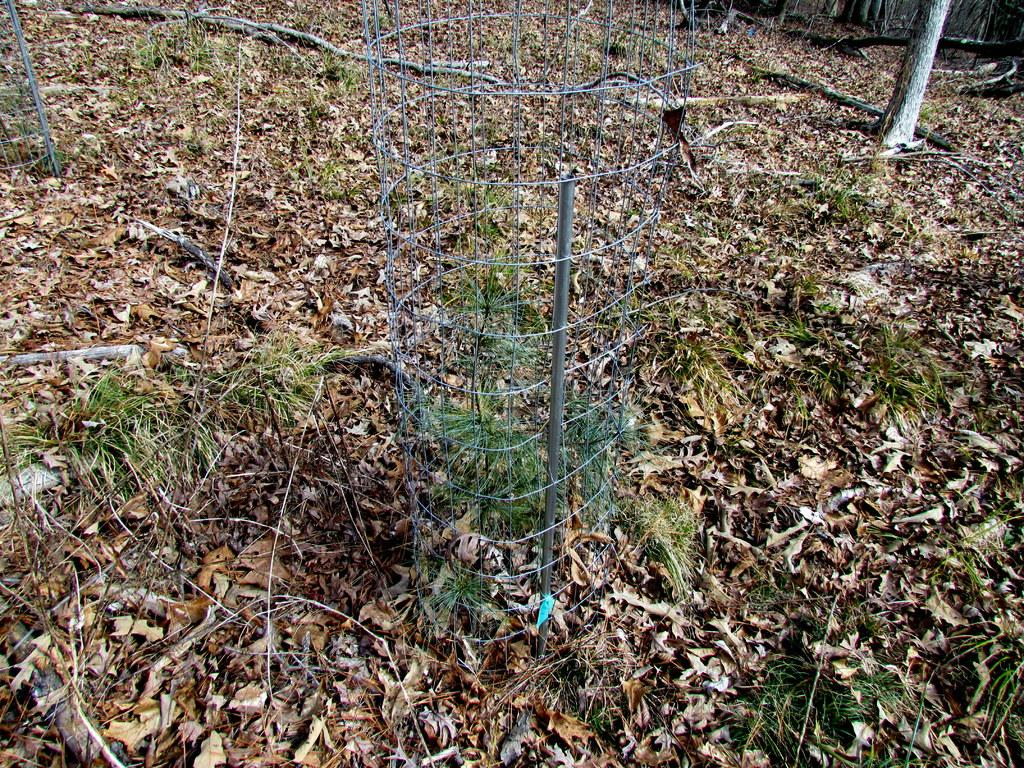What type of vegetation can be seen in the image? There are plants, grass, and trees in the image. What is the ground covered with in the image? There are leaves on the ground in the image. What type of structure is present in the image? There is a fence in the image. What can be found on the trees in the image? There are leaves on the trees in the image. What type of honey can be seen dripping from the leaves in the image? There is no honey present in the image; it only features plants, grass, trees, leaves, and a fence. 